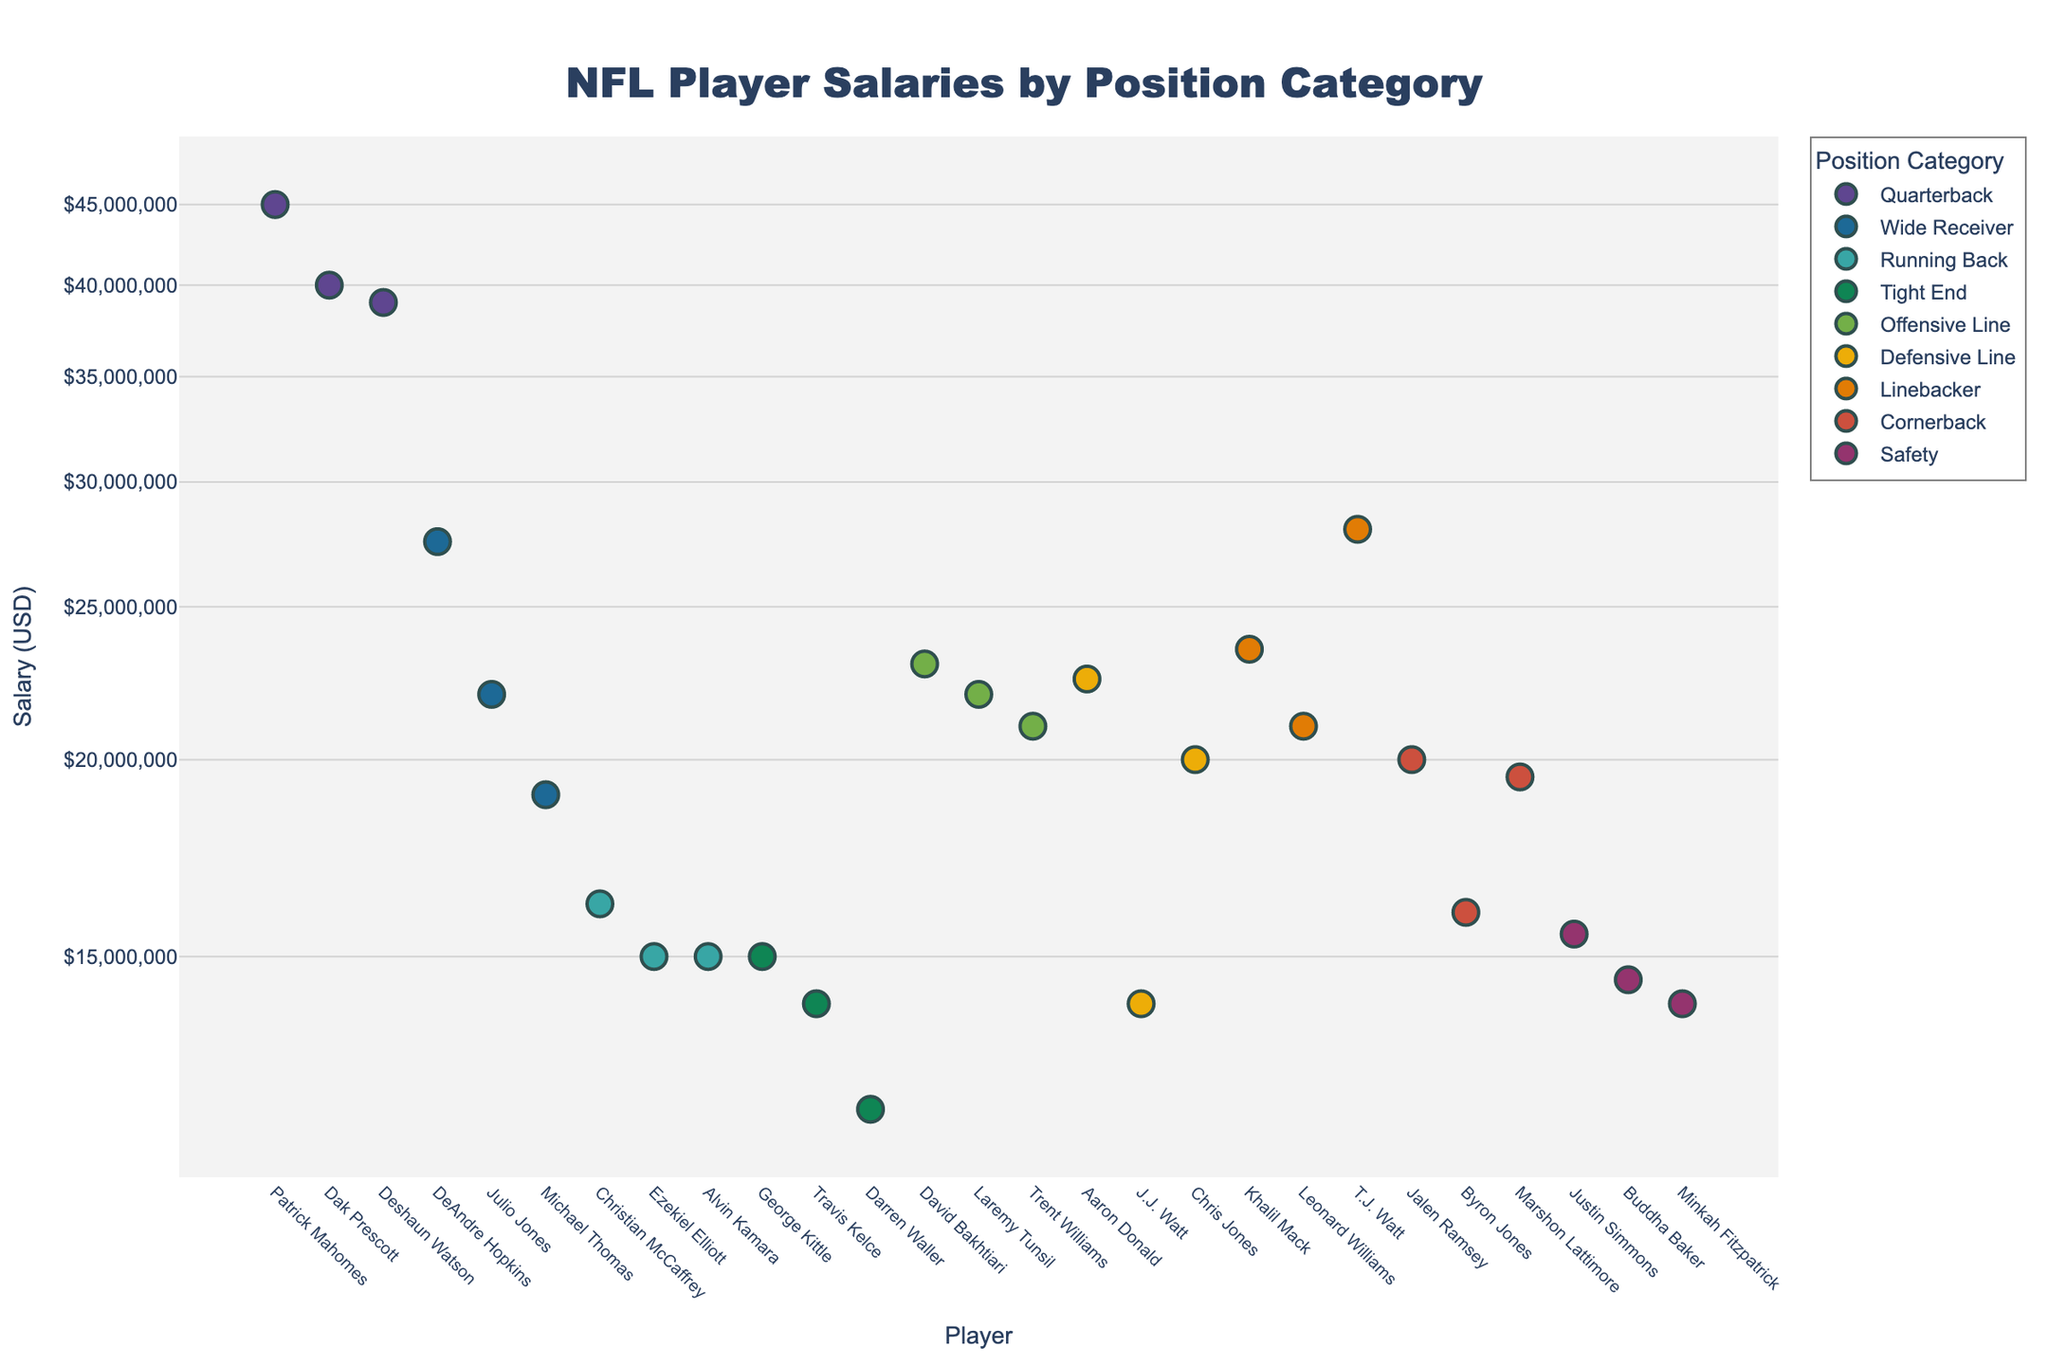what is the title of the plot? The title of the plot is located at the top of the figure and is often in a larger, bold font. It provides a quick summary of what the plot represents. In this case, the title clearly states the content of the plot.
Answer: NFL Player Salaries by Position Category How many position categories are represented in the plot? By looking at the legend or the distinct groups of points in the scatter plot, we can count the unique categories based on their colors or labels.
Answer: 7 Which player has the highest salary among the wide receivers? Locate the Wide Receiver category in the legend and find the corresponding data points in the plot. Identify the point with the highest y-coordinate value within that group.
Answer: DeAndre Hopkins What is the range of salaries for the quarterbacks? Identify the points belonging to the Quarterback category. The range is the difference between the highest and lowest y-values (salaries) among these points.
Answer: $45,000,000 to $39,000,000 Compare the highest salaries of tight ends and offensive linemen. Which position has a higher top salary, and by how much? Identify the highest salary points for the Tight End and Offensive Line categories. Subtract the maximum Tight End salary from the maximum Offensive Line salary to find the difference.
Answer: Offensive Line by $8,000,000 What's the average salary of the top three linebackers? Identify the top three linebacker salaries and sum them up. Then, divide by three to find the average.
Answer: $24,333,333.33 Considering all players, which position category has the highest salary variance? For each position category, calculate the variance of the salaries. The variance is a measure of the spread of salaries within the category.
Answer: Quarterback What is the median salary of the defensive linemen? Identify the salaries within the Defensive Line category. Sort these salaries and find the middle value to determine the median salary.
Answer: $20,000,000 Which position category has the most balanced salaries at the top three positions, meaning the smallest difference between the highest and lowest salaries among the top three earners? For each position category, find the top three salaries and calculate the difference between the highest and lowest. The category with the smallest difference has the most balanced top salaries.
Answer: Cornerback Explain the importance of using a log scale for the salary axis in this plot. Salaries range widely across different position categories, and using a log scale helps to visualize data that spans multiple orders of magnitude more clearly. It allows for smaller variations to be seen without larger values dominating the scale, making the plot easier to interpret.
Answer: Enhanced visualization of salary variation 